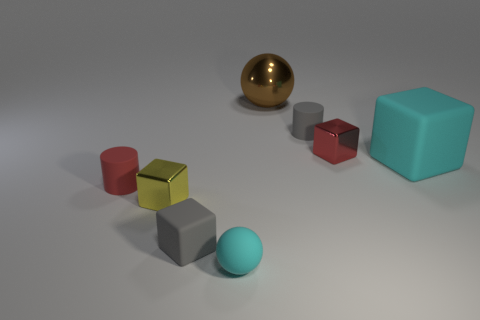Subtract all brown cubes. Subtract all green cylinders. How many cubes are left? 4 Add 2 matte objects. How many objects exist? 10 Subtract all cylinders. How many objects are left? 6 Add 8 large cyan rubber objects. How many large cyan rubber objects exist? 9 Subtract 0 green spheres. How many objects are left? 8 Subtract all cyan shiny balls. Subtract all rubber objects. How many objects are left? 3 Add 2 rubber blocks. How many rubber blocks are left? 4 